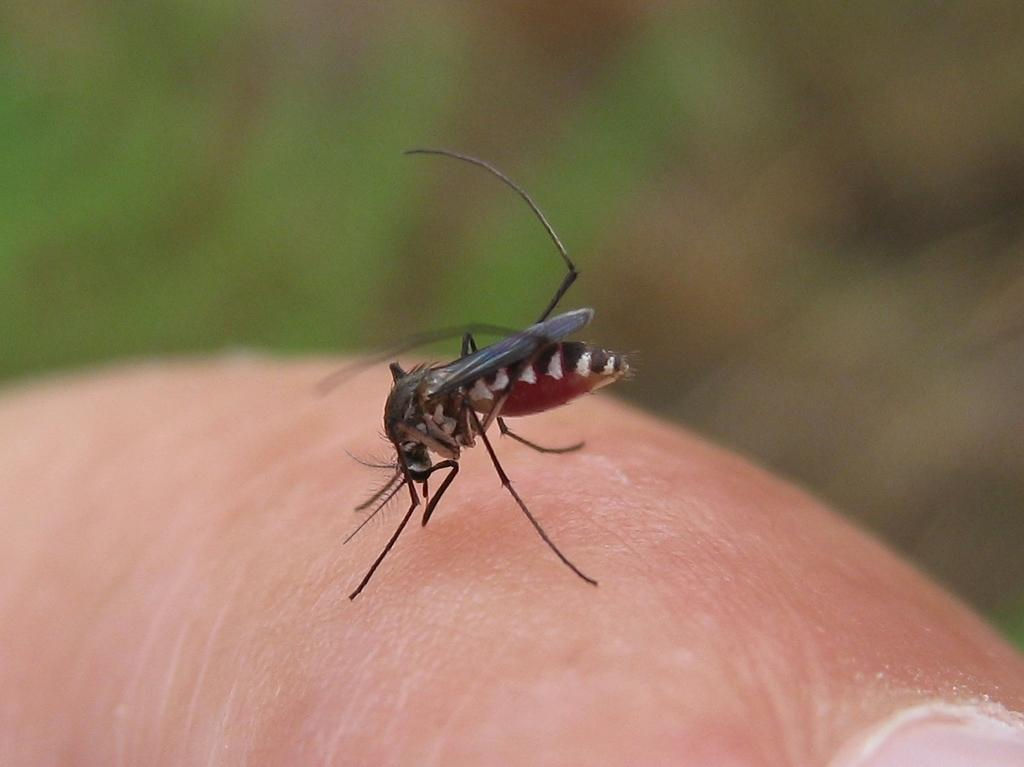What is the main subject of the image? The main subject of the image is a mosquito. Where is the mosquito located in the image? The mosquito is in the middle of the image. What is the background or setting of the image? The image appears to depict the skin, or at least include, the skin of a human at the bottom. How many dogs are present in the image? There are no dogs present in the image; it features a mosquito and what appears to be human skin. What type of medical advice can be obtained from the doctor in the image? There is no doctor present in the image; it features a mosquito and what appears to be human skin. 